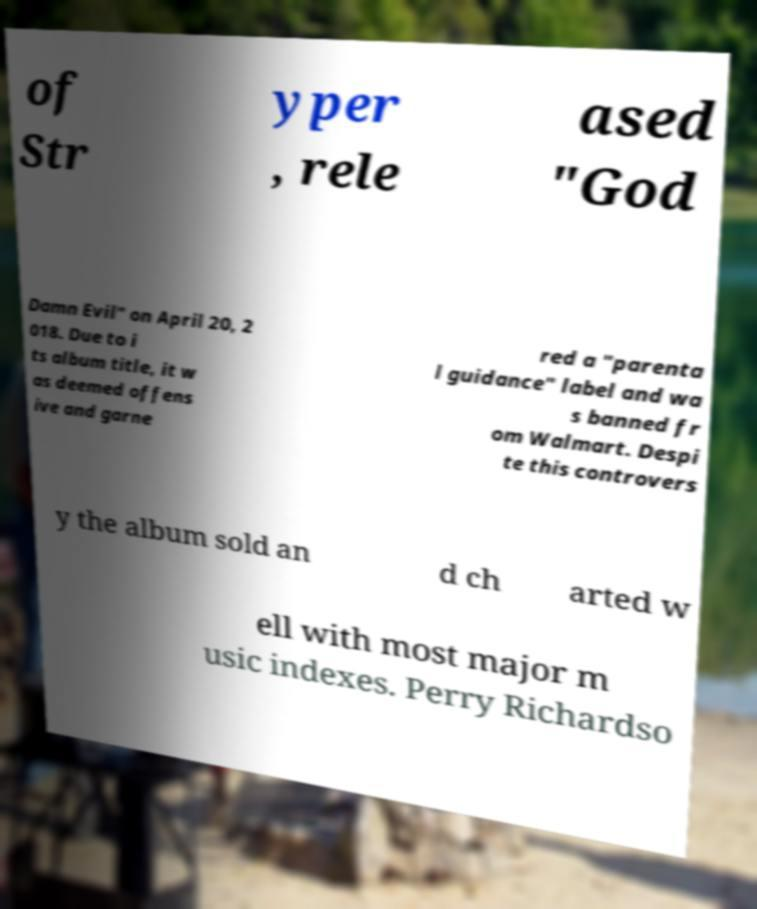Can you read and provide the text displayed in the image?This photo seems to have some interesting text. Can you extract and type it out for me? of Str yper , rele ased "God Damn Evil" on April 20, 2 018. Due to i ts album title, it w as deemed offens ive and garne red a "parenta l guidance" label and wa s banned fr om Walmart. Despi te this controvers y the album sold an d ch arted w ell with most major m usic indexes. Perry Richardso 